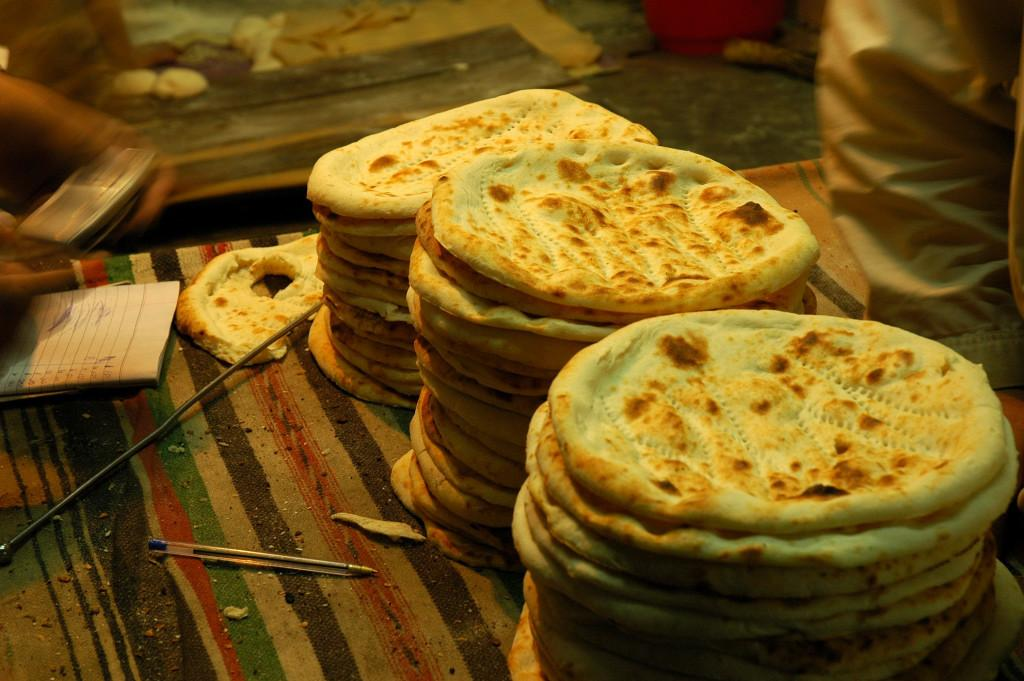What type of food is visible on the surface in the image? There are flatbreads on a surface in the image. What objects can be seen in addition to the flatbreads? There is a book and a pen in the image. Can you describe the background of the image? The background of the image is blurred. Is there any indication of a person in the image? Yes, there is a hand of a person on the right side of the image. What type of disease is being treated with the rake in the image? There is no rake or disease present in the image. Is there a slope visible in the image? There is no slope visible in the image. 